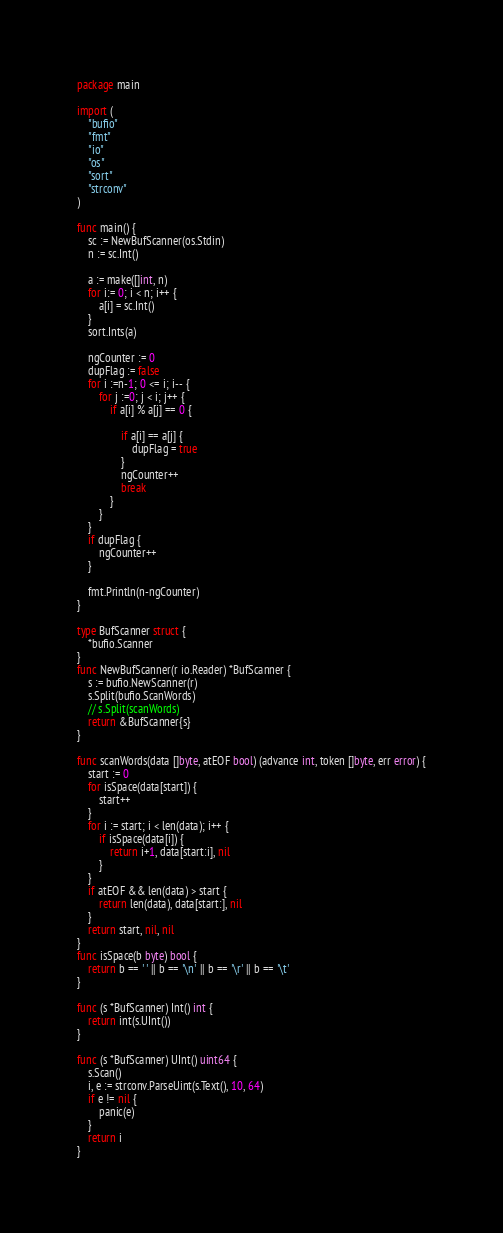<code> <loc_0><loc_0><loc_500><loc_500><_Go_>package main

import (
	"bufio"
	"fmt"
	"io"
	"os"
	"sort"
	"strconv"
)

func main() {
	sc := NewBufScanner(os.Stdin)
	n := sc.Int()

	a := make([]int, n)
	for i:= 0; i < n; i++ {
		a[i] = sc.Int()
	}
	sort.Ints(a)

	ngCounter := 0
	dupFlag := false
	for i :=n-1; 0 <= i; i-- {
		for j :=0; j < i; j++ {
			if a[i] % a[j] == 0 {

				if a[i] == a[j] {
					dupFlag = true
				}
				ngCounter++
				break
			}
		}
	}
	if dupFlag {
		ngCounter++
	}

	fmt.Println(n-ngCounter)
}

type BufScanner struct {
	*bufio.Scanner
}
func NewBufScanner(r io.Reader) *BufScanner {
	s := bufio.NewScanner(r)
	s.Split(bufio.ScanWords)
	// s.Split(scanWords)
	return &BufScanner{s}
}

func scanWords(data []byte, atEOF bool) (advance int, token []byte, err error) {
	start := 0
	for isSpace(data[start]) {
		start++
	}
	for i := start; i < len(data); i++ {
		if isSpace(data[i]) {
			return i+1, data[start:i], nil
		}
	}
	if atEOF && len(data) > start {
		return len(data), data[start:], nil
	}
	return start, nil, nil
}
func isSpace(b byte) bool {
	return b == ' ' || b == '\n' || b == '\r' || b == '\t'
}

func (s *BufScanner) Int() int {
	return int(s.UInt())
}

func (s *BufScanner) UInt() uint64 {
	s.Scan()
	i, e := strconv.ParseUint(s.Text(), 10, 64)
	if e != nil {
		panic(e)
	}
	return i
}

</code> 